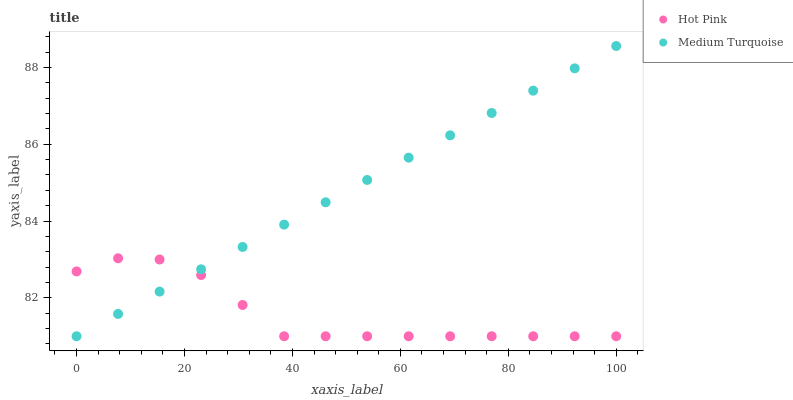Does Hot Pink have the minimum area under the curve?
Answer yes or no. Yes. Does Medium Turquoise have the maximum area under the curve?
Answer yes or no. Yes. Does Medium Turquoise have the minimum area under the curve?
Answer yes or no. No. Is Medium Turquoise the smoothest?
Answer yes or no. Yes. Is Hot Pink the roughest?
Answer yes or no. Yes. Is Medium Turquoise the roughest?
Answer yes or no. No. Does Hot Pink have the lowest value?
Answer yes or no. Yes. Does Medium Turquoise have the highest value?
Answer yes or no. Yes. Does Medium Turquoise intersect Hot Pink?
Answer yes or no. Yes. Is Medium Turquoise less than Hot Pink?
Answer yes or no. No. Is Medium Turquoise greater than Hot Pink?
Answer yes or no. No. 